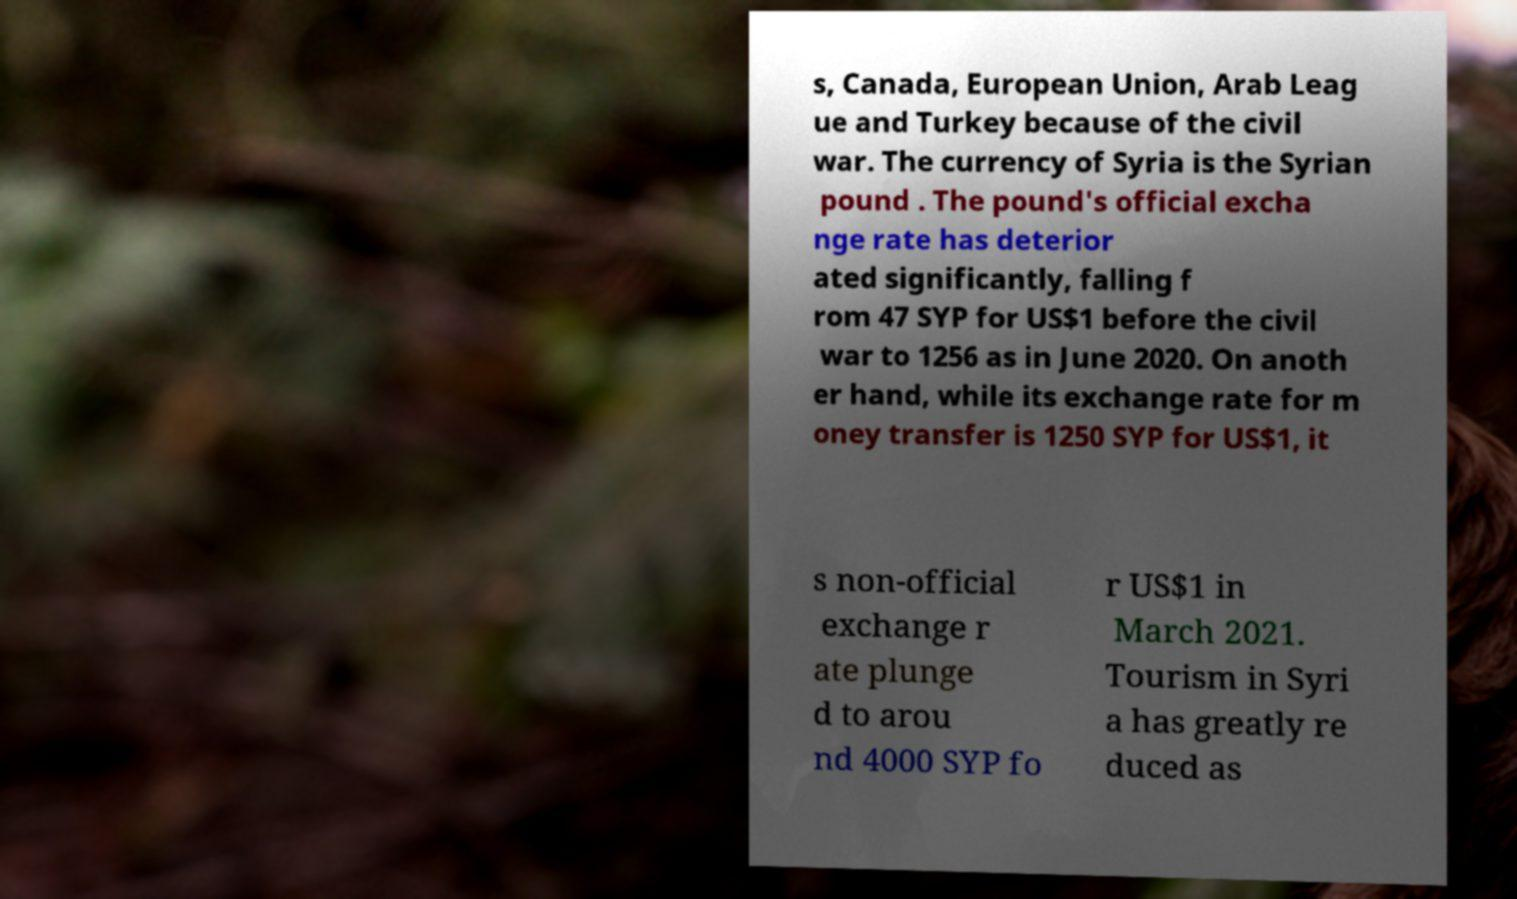There's text embedded in this image that I need extracted. Can you transcribe it verbatim? s, Canada, European Union, Arab Leag ue and Turkey because of the civil war. The currency of Syria is the Syrian pound . The pound's official excha nge rate has deterior ated significantly, falling f rom 47 SYP for US$1 before the civil war to 1256 as in June 2020. On anoth er hand, while its exchange rate for m oney transfer is 1250 SYP for US$1, it s non-official exchange r ate plunge d to arou nd 4000 SYP fo r US$1 in March 2021. Tourism in Syri a has greatly re duced as 